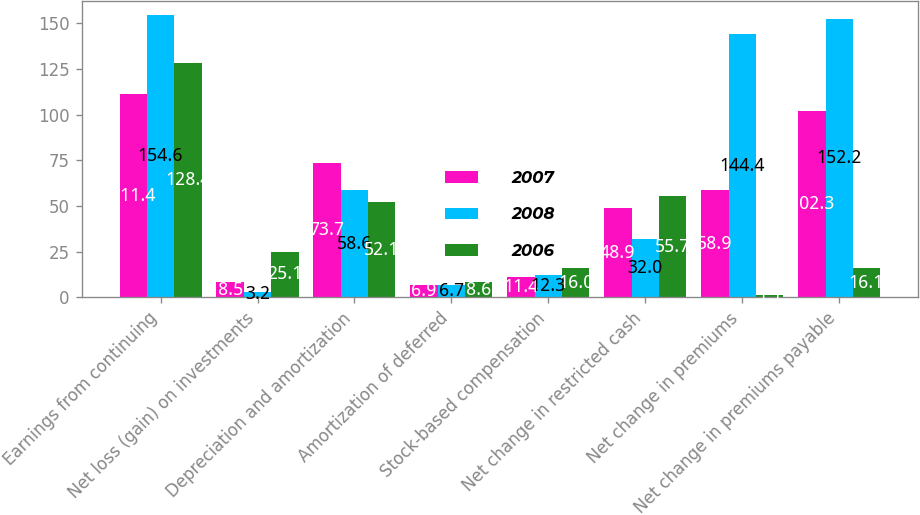<chart> <loc_0><loc_0><loc_500><loc_500><stacked_bar_chart><ecel><fcel>Earnings from continuing<fcel>Net loss (gain) on investments<fcel>Depreciation and amortization<fcel>Amortization of deferred<fcel>Stock-based compensation<fcel>Net change in restricted cash<fcel>Net change in premiums<fcel>Net change in premiums payable<nl><fcel>2007<fcel>111.4<fcel>8.5<fcel>73.7<fcel>6.9<fcel>11.4<fcel>48.9<fcel>58.9<fcel>102.3<nl><fcel>2008<fcel>154.6<fcel>3.2<fcel>58.6<fcel>6.7<fcel>12.3<fcel>32<fcel>144.4<fcel>152.2<nl><fcel>2006<fcel>128.4<fcel>25.1<fcel>52.1<fcel>8.6<fcel>16<fcel>55.7<fcel>1.1<fcel>16.1<nl></chart> 